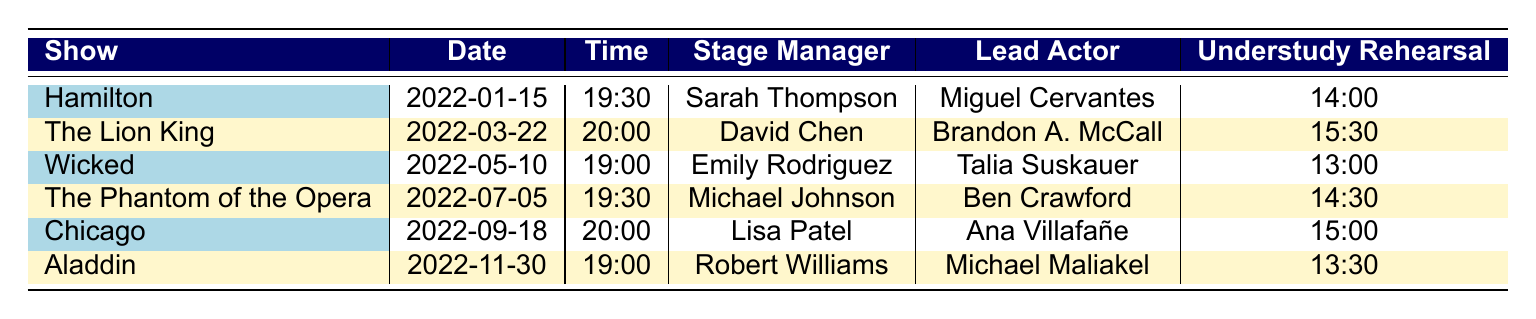What show has the latest performance date? The latest performance date in the table is for "Aladdin," which is on 2022-11-30.
Answer: Aladdin Who is the lead actor in "Wicked"? The lead actor for "Wicked" is Talia Suskauer, as indicated in the table under the corresponding show title.
Answer: Talia Suskauer What time does "The Lion King" start? "The Lion King" is scheduled to start at 20:00, as shown in the time column for that show.
Answer: 20:00 Is there an understudy rehearsal for "Chicago"? Yes, the table states that there is an understudy rehearsal for "Chicago" at 15:00.
Answer: Yes Which stage manager is associated with "Hamilton"? The stage manager for "Hamilton" is Sarah Thompson, as listed in the table.
Answer: Sarah Thompson What is the average time for understudy rehearsals across all shows? The rehearsal times are 14:00, 15:30, 13:00, 14:30, 15:00, and 13:30. Converting these times to minutes gives us: 840, 930, 780, 870, 900, 810. The average is (840 + 930 + 780 + 870 + 900 + 810) / 6 = 853.33 minutes, which corresponds to approximately 14:13 when converted back to hours and minutes.
Answer: 14:13 What is the difference in time between the earliest and latest performance times on the schedule? The earliest time is 19:00 (for "Wicked" and "Aladdin") and the latest time is 20:00 (for "The Lion King" and "Chicago"). The difference is one hour, as 20:00 - 19:00 results in 1 hour.
Answer: 1 hour Which show has the same starting time as "The Phantom of the Opera"? "Hamilton" also starts at 19:30, the same time as "The Phantom of the Opera." This is confirmed by looking at the time column for both shows.
Answer: Hamilton How many shows are scheduled for the month of September? The table shows "Chicago" as the only show scheduled in September (2022-09-18), indicating there is just one show for that month.
Answer: 1 Does "The Lion King" have the same under study rehearsal time as "Chicago"? No, "The Lion King's" understudy rehearsal time is at 15:30, while "Chicago's" is at 15:00; these times are different.
Answer: No If you include the lead actor and stage manager, how many unique individuals are listed across all shows? The unique individuals based on the lead actors and stage managers are: Sarah Thompson, Miguel Cervantes, David Chen, Brandon A. McCall, Emily Rodriguez, Talia Suskauer, Michael Johnson, Ben Crawford, Lisa Patel, Ana Villafañe, Robert Williams, and Michael Maliakel. There are 12 unique individuals when considering both roles.
Answer: 12 